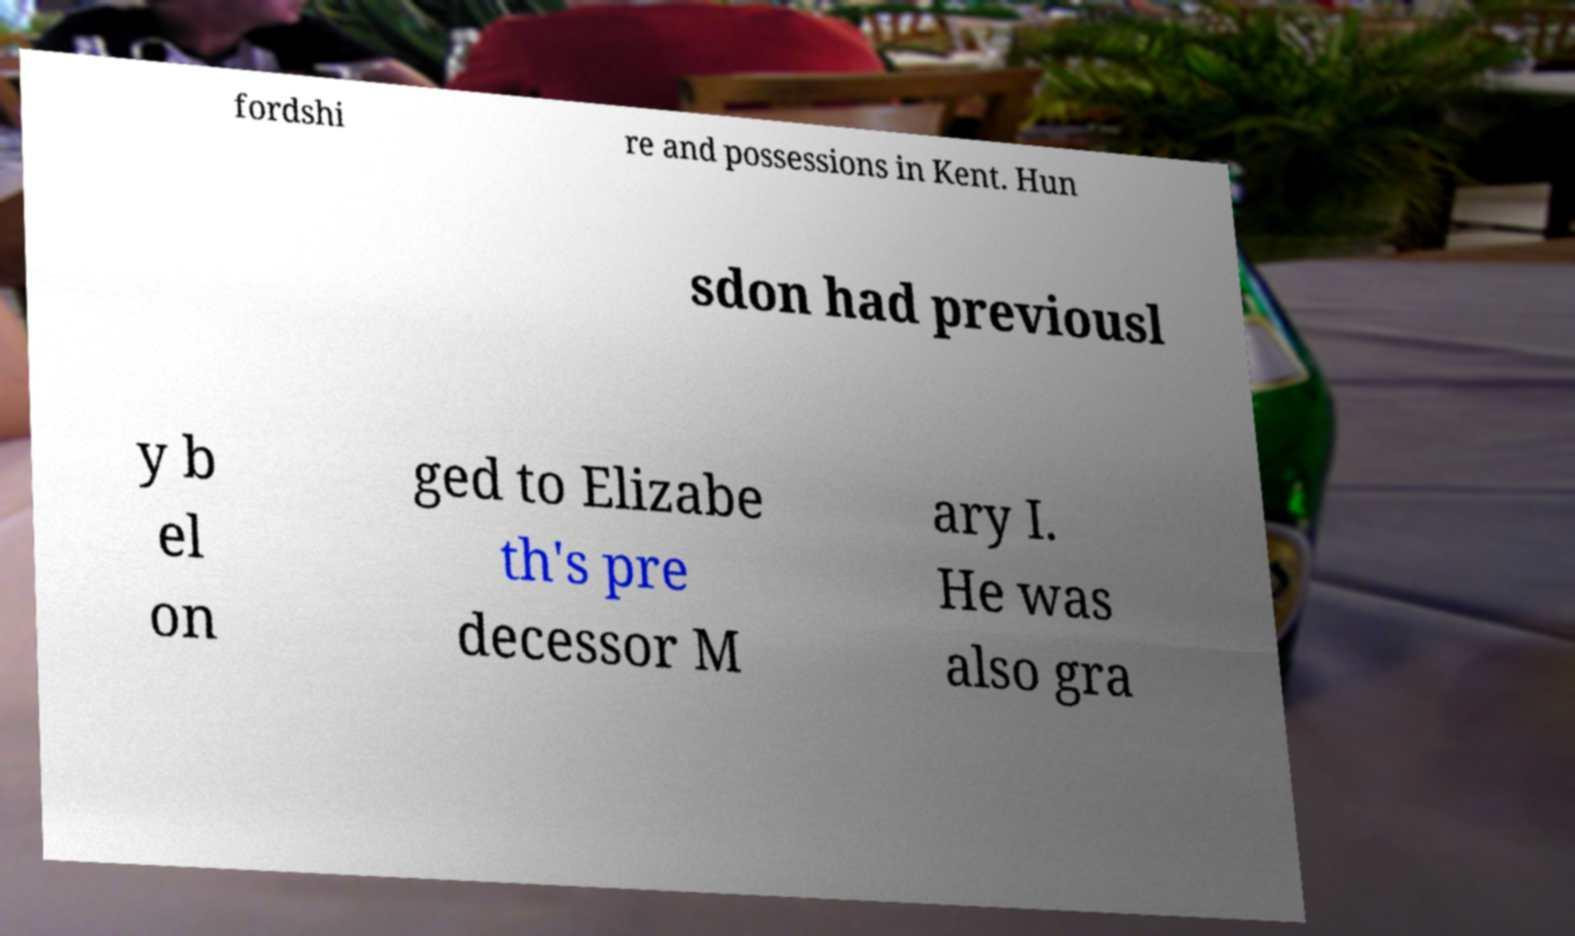Could you assist in decoding the text presented in this image and type it out clearly? fordshi re and possessions in Kent. Hun sdon had previousl y b el on ged to Elizabe th's pre decessor M ary I. He was also gra 